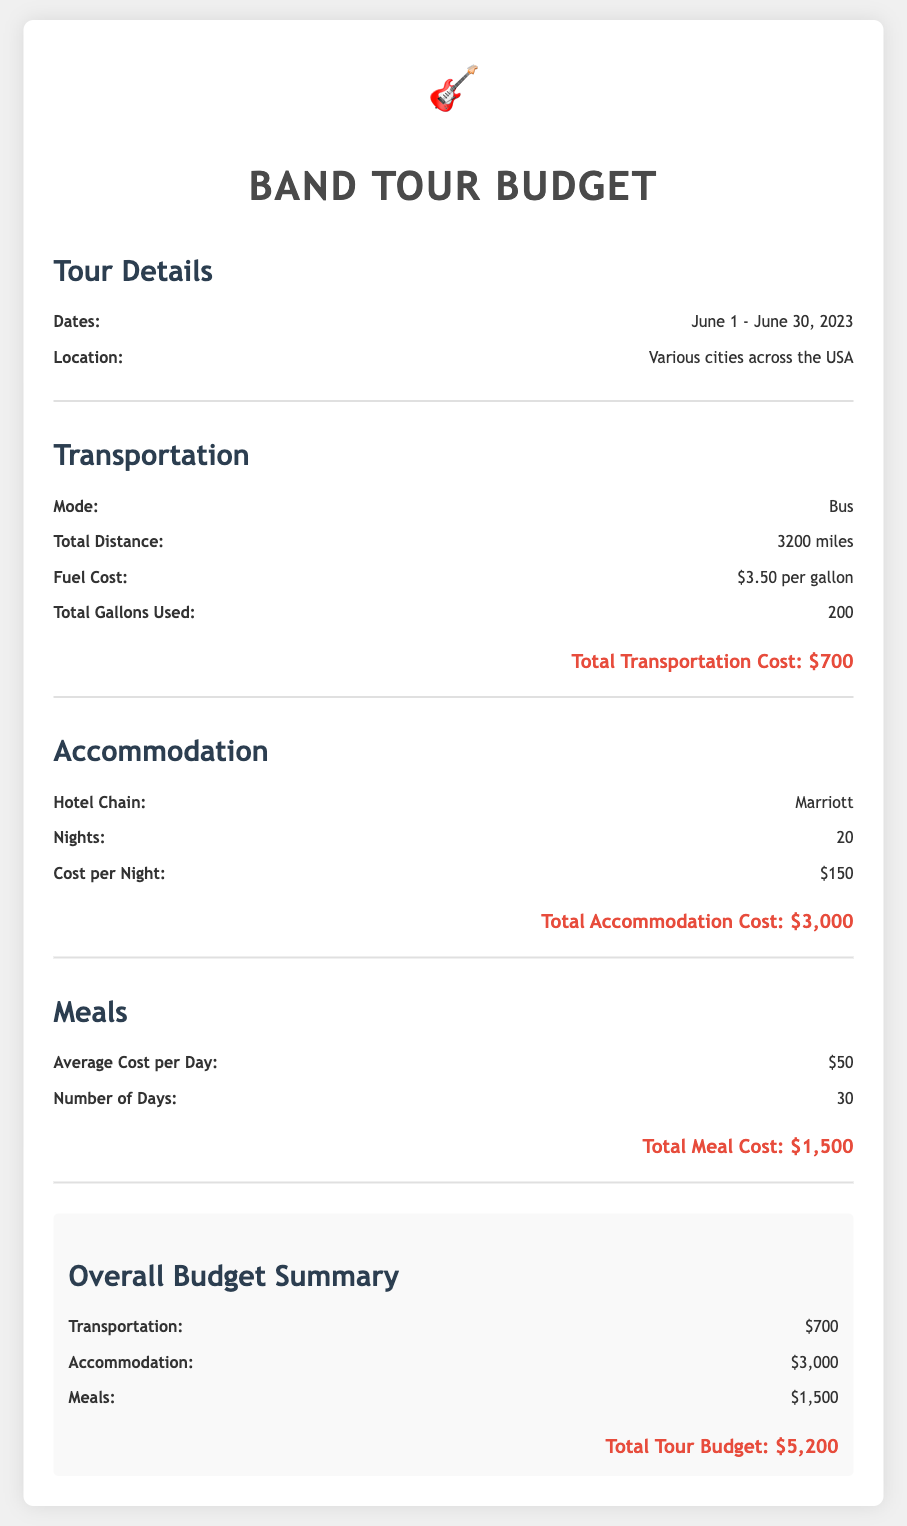What are the tour dates? The tour dates are specified in the document as June 1 - June 30, 2023.
Answer: June 1 - June 30, 2023 What is the total transportation cost? The transportation cost is calculated and presented in the section under transportation.
Answer: $700 How many nights did the band stay in hotels? The number of nights is listed in the accommodation section.
Answer: 20 What is the average meal cost per day? The average cost per day for meals is stated in the meals section.
Answer: $50 What is the total accommodation cost? The total accommodation cost can be found in the accommodation section.
Answer: $3,000 What is the total meal cost for the tour? The total meal cost is summarized in the meals section of the document.
Answer: $1,500 How much did the band spend in total for the tour? The overall budget summary combines all expenses listed in the document.
Answer: $5,200 What is the hotel chain used for accommodation? The hotel chain is clearly mentioned in the accommodation section.
Answer: Marriott 